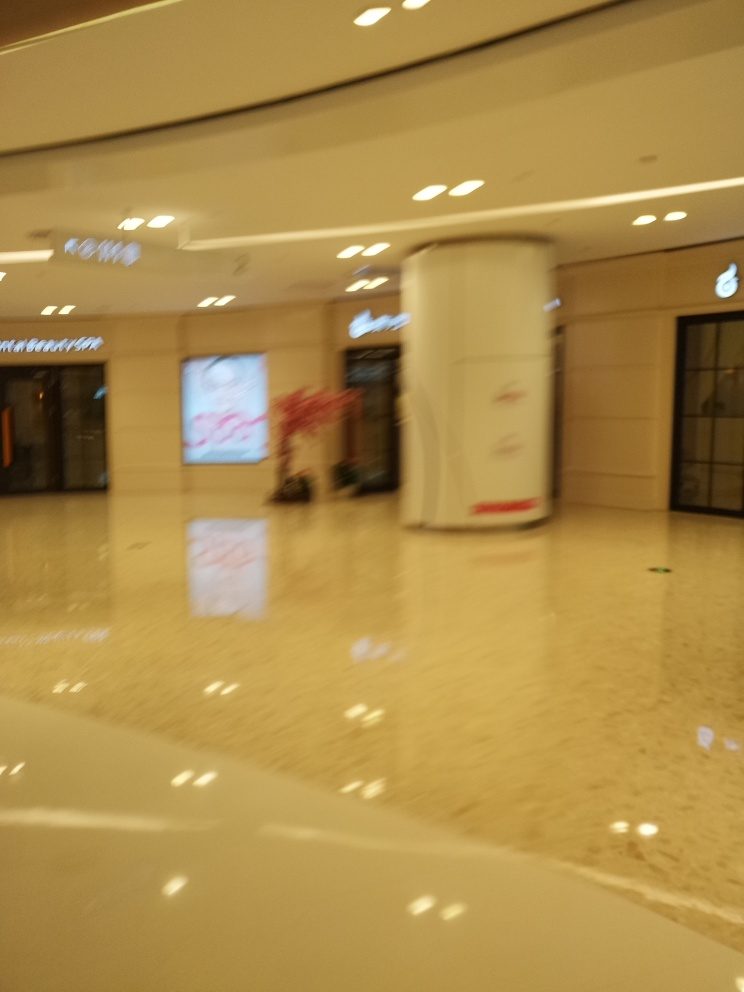Can any specific details be made out that could suggest the time of day or event? It is challenging to determine the time of day or event from the image due to its poor quality; however, the brightly lit environment and the absence of windows suggesting outdoor lighting implies it could have been taken during the evening or at night inside a well-lit enclosed space. 